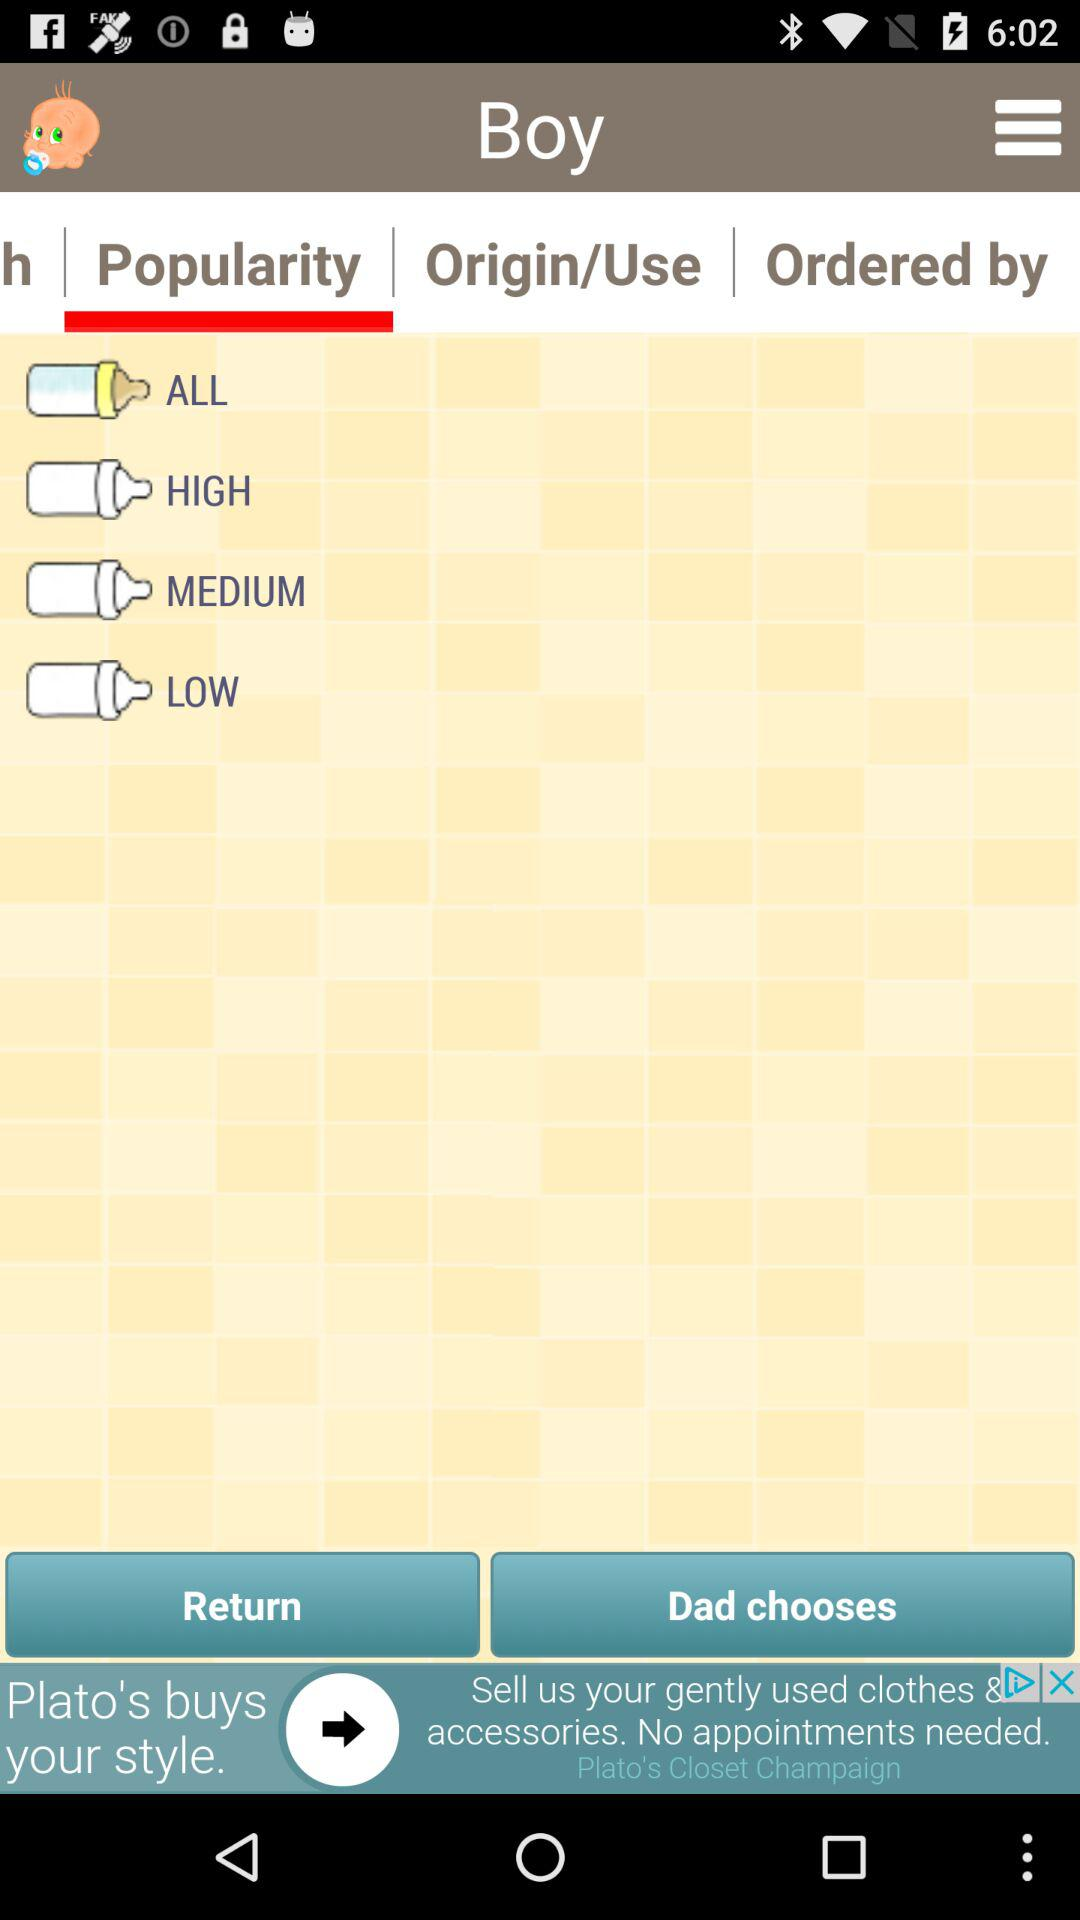What is the selected tab? The selected tab is "Popularity". 